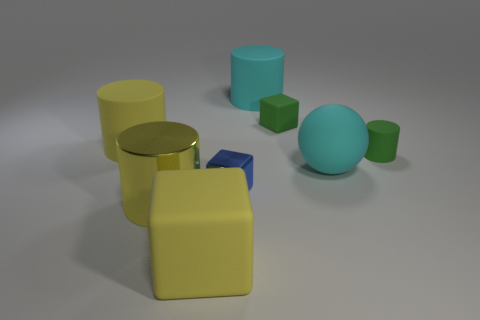There is a tiny thing that is the same color as the tiny matte block; what is its material?
Your response must be concise. Rubber. Do the large matte block and the big metal cylinder have the same color?
Make the answer very short. Yes. Are there any other things that are the same color as the tiny metallic object?
Provide a succinct answer. No. The other cube that is made of the same material as the big yellow block is what size?
Provide a succinct answer. Small. There is a yellow metal thing; is it the same shape as the big cyan rubber object that is behind the small green rubber block?
Keep it short and to the point. Yes. How big is the blue thing?
Your response must be concise. Small. Is the number of big yellow objects that are behind the yellow matte cylinder less than the number of large blue rubber objects?
Your answer should be very brief. No. What number of green rubber cubes have the same size as the blue cube?
Offer a terse response. 1. There is a rubber thing that is the same color as the big ball; what shape is it?
Provide a short and direct response. Cylinder. Is the color of the big cylinder that is to the right of the blue metallic thing the same as the rubber block to the right of the cyan cylinder?
Give a very brief answer. No. 